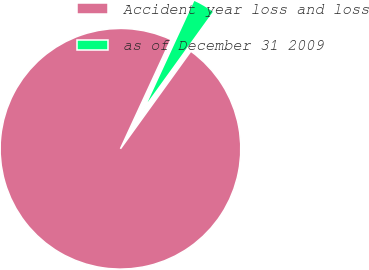Convert chart. <chart><loc_0><loc_0><loc_500><loc_500><pie_chart><fcel>Accident year loss and loss<fcel>as of December 31 2009<nl><fcel>96.94%<fcel>3.06%<nl></chart> 